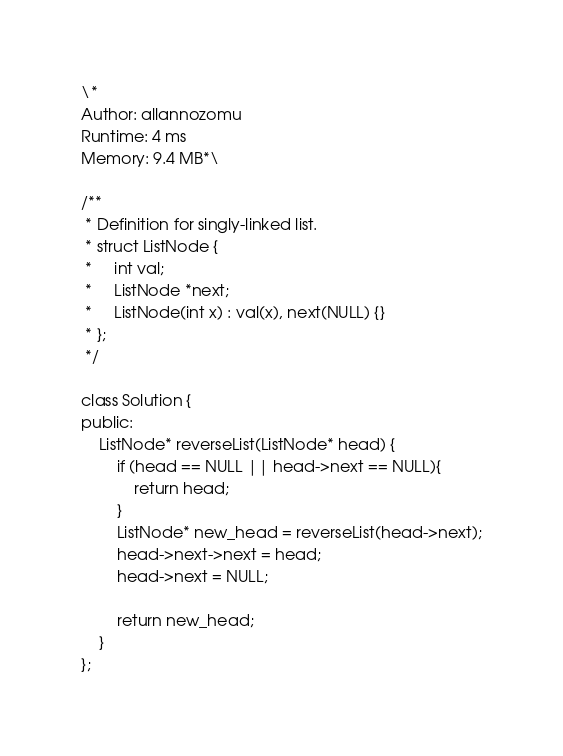Convert code to text. <code><loc_0><loc_0><loc_500><loc_500><_C++_>\*
Author: allannozomu
Runtime: 4 ms
Memory: 9.4 MB*\

/**
 * Definition for singly-linked list.
 * struct ListNode {
 *     int val;
 *     ListNode *next;
 *     ListNode(int x) : val(x), next(NULL) {}
 * };
 */

class Solution {
public:
    ListNode* reverseList(ListNode* head) {
        if (head == NULL || head->next == NULL){
            return head;
        }
        ListNode* new_head = reverseList(head->next);
        head->next->next = head;
        head->next = NULL;
            
        return new_head;
    }
};</code> 